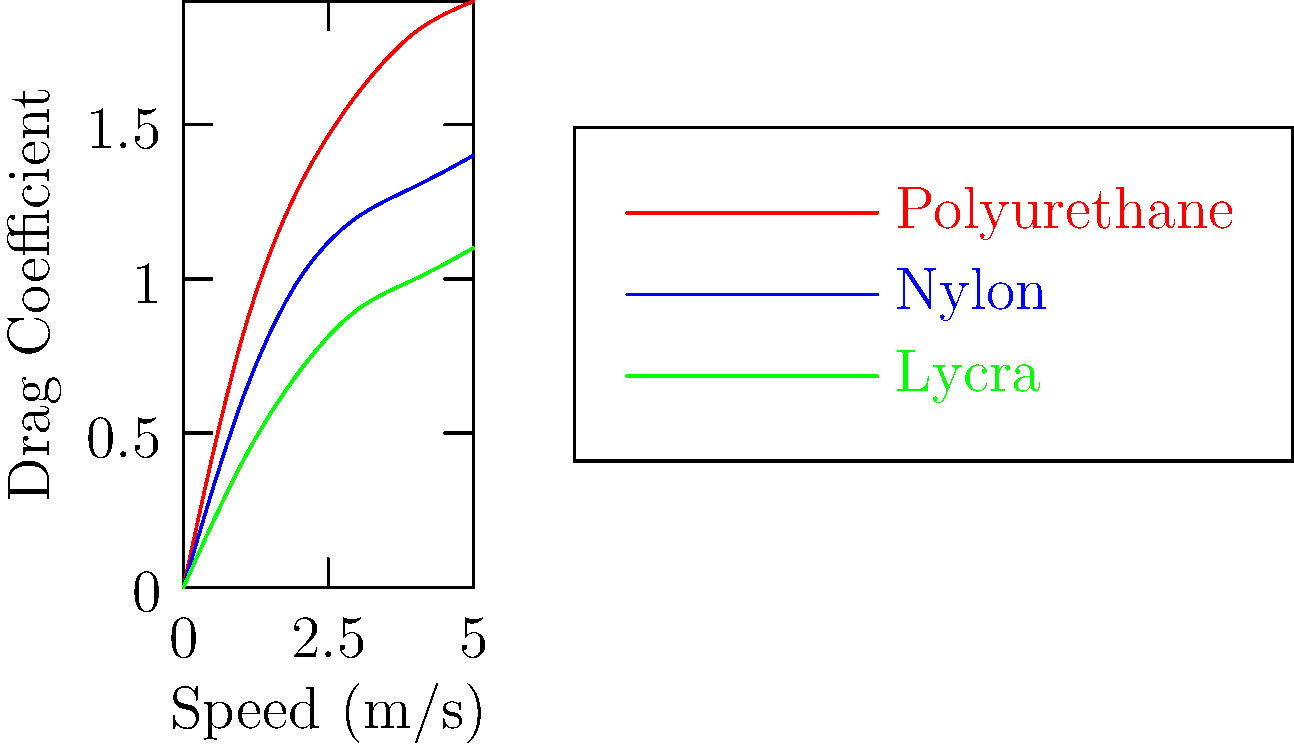As a swimming enthusiast, you're analyzing the hydrodynamic properties of various swimsuit materials. The graph shows the relationship between speed and drag coefficient for three materials: polyurethane, nylon, and Lycra. At a speed of 3 m/s, which material exhibits the lowest drag coefficient, and by approximately what percentage is it lower than the highest drag coefficient at the same speed? To answer this question, we need to follow these steps:

1. Identify the drag coefficients at 3 m/s for each material:
   - Polyurethane (red line): ~1.6
   - Nylon (blue line): ~1.2
   - Lycra (green line): ~0.9

2. Determine the material with the lowest drag coefficient:
   Lycra has the lowest drag coefficient at ~0.9.

3. Identify the material with the highest drag coefficient:
   Polyurethane has the highest drag coefficient at ~1.6.

4. Calculate the percentage difference:
   Percentage difference = $\frac{\text{Highest} - \text{Lowest}}{\text{Highest}} \times 100\%$
   $= \frac{1.6 - 0.9}{1.6} \times 100\% = \frac{0.7}{1.6} \times 100\% \approx 43.75\%$

Therefore, Lycra exhibits the lowest drag coefficient at 3 m/s, and it is approximately 43.75% lower than the highest drag coefficient (polyurethane) at the same speed.
Answer: Lycra, ~43.75% lower 